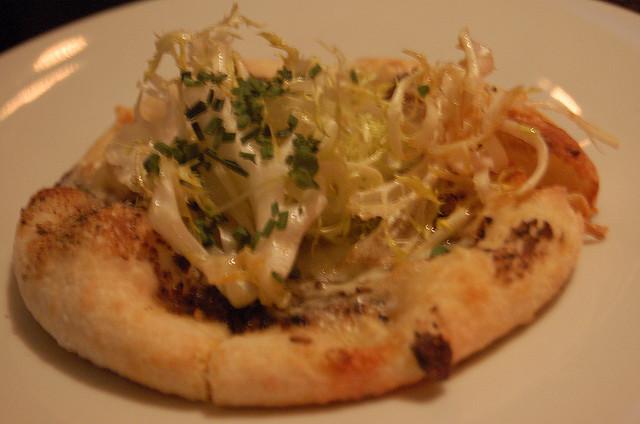Is this a pizza?
Be succinct. Yes. Does the pizza fill the plate?
Short answer required. No. Are these made from tortillas?
Quick response, please. No. Is the food on a plate?
Be succinct. Yes. What kind of sauce is on this food?
Short answer required. Tomato. 